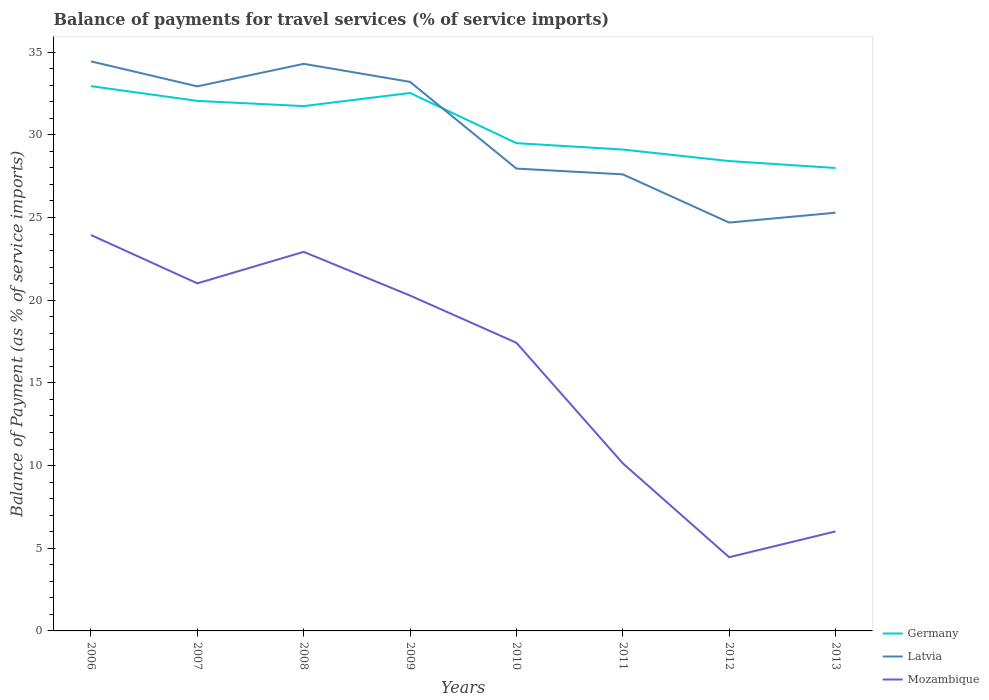How many different coloured lines are there?
Your answer should be very brief. 3. Is the number of lines equal to the number of legend labels?
Your answer should be very brief. Yes. Across all years, what is the maximum balance of payments for travel services in Latvia?
Provide a succinct answer. 24.69. What is the total balance of payments for travel services in Latvia in the graph?
Make the answer very short. 1.51. What is the difference between the highest and the second highest balance of payments for travel services in Germany?
Offer a very short reply. 4.95. Is the balance of payments for travel services in Mozambique strictly greater than the balance of payments for travel services in Germany over the years?
Your answer should be very brief. Yes. How many lines are there?
Your answer should be compact. 3. What is the difference between two consecutive major ticks on the Y-axis?
Keep it short and to the point. 5. How are the legend labels stacked?
Ensure brevity in your answer.  Vertical. What is the title of the graph?
Offer a very short reply. Balance of payments for travel services (% of service imports). What is the label or title of the X-axis?
Offer a terse response. Years. What is the label or title of the Y-axis?
Give a very brief answer. Balance of Payment (as % of service imports). What is the Balance of Payment (as % of service imports) in Germany in 2006?
Ensure brevity in your answer.  32.95. What is the Balance of Payment (as % of service imports) in Latvia in 2006?
Offer a terse response. 34.44. What is the Balance of Payment (as % of service imports) of Mozambique in 2006?
Make the answer very short. 23.94. What is the Balance of Payment (as % of service imports) in Germany in 2007?
Your response must be concise. 32.05. What is the Balance of Payment (as % of service imports) of Latvia in 2007?
Your response must be concise. 32.93. What is the Balance of Payment (as % of service imports) of Mozambique in 2007?
Offer a very short reply. 21.02. What is the Balance of Payment (as % of service imports) in Germany in 2008?
Give a very brief answer. 31.74. What is the Balance of Payment (as % of service imports) in Latvia in 2008?
Your answer should be compact. 34.29. What is the Balance of Payment (as % of service imports) in Mozambique in 2008?
Your answer should be compact. 22.92. What is the Balance of Payment (as % of service imports) in Germany in 2009?
Your answer should be very brief. 32.53. What is the Balance of Payment (as % of service imports) of Latvia in 2009?
Your answer should be compact. 33.2. What is the Balance of Payment (as % of service imports) in Mozambique in 2009?
Offer a terse response. 20.28. What is the Balance of Payment (as % of service imports) of Germany in 2010?
Provide a short and direct response. 29.5. What is the Balance of Payment (as % of service imports) in Latvia in 2010?
Provide a short and direct response. 27.96. What is the Balance of Payment (as % of service imports) of Mozambique in 2010?
Your answer should be very brief. 17.43. What is the Balance of Payment (as % of service imports) of Germany in 2011?
Keep it short and to the point. 29.11. What is the Balance of Payment (as % of service imports) in Latvia in 2011?
Keep it short and to the point. 27.61. What is the Balance of Payment (as % of service imports) of Mozambique in 2011?
Your answer should be very brief. 10.14. What is the Balance of Payment (as % of service imports) in Germany in 2012?
Keep it short and to the point. 28.41. What is the Balance of Payment (as % of service imports) in Latvia in 2012?
Keep it short and to the point. 24.69. What is the Balance of Payment (as % of service imports) of Mozambique in 2012?
Your answer should be compact. 4.46. What is the Balance of Payment (as % of service imports) in Germany in 2013?
Offer a terse response. 27.99. What is the Balance of Payment (as % of service imports) in Latvia in 2013?
Make the answer very short. 25.29. What is the Balance of Payment (as % of service imports) of Mozambique in 2013?
Keep it short and to the point. 6.02. Across all years, what is the maximum Balance of Payment (as % of service imports) in Germany?
Make the answer very short. 32.95. Across all years, what is the maximum Balance of Payment (as % of service imports) of Latvia?
Offer a very short reply. 34.44. Across all years, what is the maximum Balance of Payment (as % of service imports) in Mozambique?
Keep it short and to the point. 23.94. Across all years, what is the minimum Balance of Payment (as % of service imports) of Germany?
Your answer should be compact. 27.99. Across all years, what is the minimum Balance of Payment (as % of service imports) in Latvia?
Your answer should be compact. 24.69. Across all years, what is the minimum Balance of Payment (as % of service imports) in Mozambique?
Offer a terse response. 4.46. What is the total Balance of Payment (as % of service imports) in Germany in the graph?
Your response must be concise. 244.29. What is the total Balance of Payment (as % of service imports) of Latvia in the graph?
Your answer should be compact. 240.43. What is the total Balance of Payment (as % of service imports) in Mozambique in the graph?
Provide a succinct answer. 126.21. What is the difference between the Balance of Payment (as % of service imports) in Germany in 2006 and that in 2007?
Make the answer very short. 0.89. What is the difference between the Balance of Payment (as % of service imports) in Latvia in 2006 and that in 2007?
Your response must be concise. 1.51. What is the difference between the Balance of Payment (as % of service imports) in Mozambique in 2006 and that in 2007?
Provide a succinct answer. 2.92. What is the difference between the Balance of Payment (as % of service imports) of Germany in 2006 and that in 2008?
Your answer should be compact. 1.21. What is the difference between the Balance of Payment (as % of service imports) of Latvia in 2006 and that in 2008?
Offer a very short reply. 0.15. What is the difference between the Balance of Payment (as % of service imports) of Mozambique in 2006 and that in 2008?
Give a very brief answer. 1.02. What is the difference between the Balance of Payment (as % of service imports) in Germany in 2006 and that in 2009?
Provide a succinct answer. 0.41. What is the difference between the Balance of Payment (as % of service imports) in Latvia in 2006 and that in 2009?
Provide a succinct answer. 1.24. What is the difference between the Balance of Payment (as % of service imports) of Mozambique in 2006 and that in 2009?
Your answer should be very brief. 3.66. What is the difference between the Balance of Payment (as % of service imports) of Germany in 2006 and that in 2010?
Your response must be concise. 3.45. What is the difference between the Balance of Payment (as % of service imports) in Latvia in 2006 and that in 2010?
Your response must be concise. 6.48. What is the difference between the Balance of Payment (as % of service imports) in Mozambique in 2006 and that in 2010?
Make the answer very short. 6.51. What is the difference between the Balance of Payment (as % of service imports) of Germany in 2006 and that in 2011?
Offer a very short reply. 3.84. What is the difference between the Balance of Payment (as % of service imports) of Latvia in 2006 and that in 2011?
Provide a succinct answer. 6.83. What is the difference between the Balance of Payment (as % of service imports) of Mozambique in 2006 and that in 2011?
Give a very brief answer. 13.8. What is the difference between the Balance of Payment (as % of service imports) in Germany in 2006 and that in 2012?
Your answer should be compact. 4.53. What is the difference between the Balance of Payment (as % of service imports) of Latvia in 2006 and that in 2012?
Keep it short and to the point. 9.75. What is the difference between the Balance of Payment (as % of service imports) of Mozambique in 2006 and that in 2012?
Offer a terse response. 19.48. What is the difference between the Balance of Payment (as % of service imports) of Germany in 2006 and that in 2013?
Provide a short and direct response. 4.95. What is the difference between the Balance of Payment (as % of service imports) in Latvia in 2006 and that in 2013?
Give a very brief answer. 9.15. What is the difference between the Balance of Payment (as % of service imports) in Mozambique in 2006 and that in 2013?
Offer a very short reply. 17.92. What is the difference between the Balance of Payment (as % of service imports) in Germany in 2007 and that in 2008?
Provide a short and direct response. 0.32. What is the difference between the Balance of Payment (as % of service imports) of Latvia in 2007 and that in 2008?
Keep it short and to the point. -1.36. What is the difference between the Balance of Payment (as % of service imports) of Mozambique in 2007 and that in 2008?
Make the answer very short. -1.9. What is the difference between the Balance of Payment (as % of service imports) of Germany in 2007 and that in 2009?
Your response must be concise. -0.48. What is the difference between the Balance of Payment (as % of service imports) of Latvia in 2007 and that in 2009?
Offer a very short reply. -0.27. What is the difference between the Balance of Payment (as % of service imports) in Mozambique in 2007 and that in 2009?
Keep it short and to the point. 0.74. What is the difference between the Balance of Payment (as % of service imports) of Germany in 2007 and that in 2010?
Give a very brief answer. 2.56. What is the difference between the Balance of Payment (as % of service imports) of Latvia in 2007 and that in 2010?
Give a very brief answer. 4.97. What is the difference between the Balance of Payment (as % of service imports) in Mozambique in 2007 and that in 2010?
Provide a succinct answer. 3.59. What is the difference between the Balance of Payment (as % of service imports) in Germany in 2007 and that in 2011?
Provide a short and direct response. 2.94. What is the difference between the Balance of Payment (as % of service imports) in Latvia in 2007 and that in 2011?
Offer a very short reply. 5.32. What is the difference between the Balance of Payment (as % of service imports) in Mozambique in 2007 and that in 2011?
Ensure brevity in your answer.  10.88. What is the difference between the Balance of Payment (as % of service imports) in Germany in 2007 and that in 2012?
Make the answer very short. 3.64. What is the difference between the Balance of Payment (as % of service imports) in Latvia in 2007 and that in 2012?
Offer a very short reply. 8.24. What is the difference between the Balance of Payment (as % of service imports) of Mozambique in 2007 and that in 2012?
Ensure brevity in your answer.  16.56. What is the difference between the Balance of Payment (as % of service imports) of Germany in 2007 and that in 2013?
Your answer should be compact. 4.06. What is the difference between the Balance of Payment (as % of service imports) of Latvia in 2007 and that in 2013?
Provide a succinct answer. 7.64. What is the difference between the Balance of Payment (as % of service imports) in Mozambique in 2007 and that in 2013?
Your response must be concise. 15. What is the difference between the Balance of Payment (as % of service imports) of Germany in 2008 and that in 2009?
Ensure brevity in your answer.  -0.79. What is the difference between the Balance of Payment (as % of service imports) in Latvia in 2008 and that in 2009?
Your answer should be compact. 1.09. What is the difference between the Balance of Payment (as % of service imports) of Mozambique in 2008 and that in 2009?
Offer a terse response. 2.64. What is the difference between the Balance of Payment (as % of service imports) of Germany in 2008 and that in 2010?
Offer a very short reply. 2.24. What is the difference between the Balance of Payment (as % of service imports) of Latvia in 2008 and that in 2010?
Keep it short and to the point. 6.33. What is the difference between the Balance of Payment (as % of service imports) of Mozambique in 2008 and that in 2010?
Provide a succinct answer. 5.5. What is the difference between the Balance of Payment (as % of service imports) of Germany in 2008 and that in 2011?
Offer a very short reply. 2.63. What is the difference between the Balance of Payment (as % of service imports) in Latvia in 2008 and that in 2011?
Give a very brief answer. 6.68. What is the difference between the Balance of Payment (as % of service imports) of Mozambique in 2008 and that in 2011?
Provide a succinct answer. 12.79. What is the difference between the Balance of Payment (as % of service imports) of Germany in 2008 and that in 2012?
Provide a short and direct response. 3.32. What is the difference between the Balance of Payment (as % of service imports) of Latvia in 2008 and that in 2012?
Provide a succinct answer. 9.6. What is the difference between the Balance of Payment (as % of service imports) of Mozambique in 2008 and that in 2012?
Offer a terse response. 18.47. What is the difference between the Balance of Payment (as % of service imports) of Germany in 2008 and that in 2013?
Your response must be concise. 3.74. What is the difference between the Balance of Payment (as % of service imports) in Latvia in 2008 and that in 2013?
Keep it short and to the point. 9. What is the difference between the Balance of Payment (as % of service imports) in Mozambique in 2008 and that in 2013?
Provide a short and direct response. 16.91. What is the difference between the Balance of Payment (as % of service imports) of Germany in 2009 and that in 2010?
Offer a terse response. 3.03. What is the difference between the Balance of Payment (as % of service imports) of Latvia in 2009 and that in 2010?
Keep it short and to the point. 5.24. What is the difference between the Balance of Payment (as % of service imports) of Mozambique in 2009 and that in 2010?
Provide a short and direct response. 2.86. What is the difference between the Balance of Payment (as % of service imports) of Germany in 2009 and that in 2011?
Provide a succinct answer. 3.42. What is the difference between the Balance of Payment (as % of service imports) of Latvia in 2009 and that in 2011?
Give a very brief answer. 5.59. What is the difference between the Balance of Payment (as % of service imports) in Mozambique in 2009 and that in 2011?
Give a very brief answer. 10.14. What is the difference between the Balance of Payment (as % of service imports) of Germany in 2009 and that in 2012?
Provide a short and direct response. 4.12. What is the difference between the Balance of Payment (as % of service imports) in Latvia in 2009 and that in 2012?
Offer a terse response. 8.51. What is the difference between the Balance of Payment (as % of service imports) in Mozambique in 2009 and that in 2012?
Your response must be concise. 15.82. What is the difference between the Balance of Payment (as % of service imports) in Germany in 2009 and that in 2013?
Provide a succinct answer. 4.54. What is the difference between the Balance of Payment (as % of service imports) of Latvia in 2009 and that in 2013?
Your response must be concise. 7.91. What is the difference between the Balance of Payment (as % of service imports) of Mozambique in 2009 and that in 2013?
Offer a terse response. 14.26. What is the difference between the Balance of Payment (as % of service imports) in Germany in 2010 and that in 2011?
Give a very brief answer. 0.39. What is the difference between the Balance of Payment (as % of service imports) of Latvia in 2010 and that in 2011?
Your answer should be very brief. 0.35. What is the difference between the Balance of Payment (as % of service imports) in Mozambique in 2010 and that in 2011?
Your answer should be very brief. 7.29. What is the difference between the Balance of Payment (as % of service imports) in Germany in 2010 and that in 2012?
Your answer should be compact. 1.08. What is the difference between the Balance of Payment (as % of service imports) of Latvia in 2010 and that in 2012?
Your response must be concise. 3.26. What is the difference between the Balance of Payment (as % of service imports) in Mozambique in 2010 and that in 2012?
Provide a short and direct response. 12.97. What is the difference between the Balance of Payment (as % of service imports) of Germany in 2010 and that in 2013?
Make the answer very short. 1.5. What is the difference between the Balance of Payment (as % of service imports) of Latvia in 2010 and that in 2013?
Keep it short and to the point. 2.67. What is the difference between the Balance of Payment (as % of service imports) of Mozambique in 2010 and that in 2013?
Your answer should be compact. 11.41. What is the difference between the Balance of Payment (as % of service imports) in Germany in 2011 and that in 2012?
Provide a short and direct response. 0.69. What is the difference between the Balance of Payment (as % of service imports) in Latvia in 2011 and that in 2012?
Make the answer very short. 2.92. What is the difference between the Balance of Payment (as % of service imports) of Mozambique in 2011 and that in 2012?
Make the answer very short. 5.68. What is the difference between the Balance of Payment (as % of service imports) in Germany in 2011 and that in 2013?
Make the answer very short. 1.11. What is the difference between the Balance of Payment (as % of service imports) in Latvia in 2011 and that in 2013?
Provide a short and direct response. 2.32. What is the difference between the Balance of Payment (as % of service imports) of Mozambique in 2011 and that in 2013?
Your answer should be very brief. 4.12. What is the difference between the Balance of Payment (as % of service imports) in Germany in 2012 and that in 2013?
Your response must be concise. 0.42. What is the difference between the Balance of Payment (as % of service imports) of Latvia in 2012 and that in 2013?
Offer a terse response. -0.6. What is the difference between the Balance of Payment (as % of service imports) of Mozambique in 2012 and that in 2013?
Offer a terse response. -1.56. What is the difference between the Balance of Payment (as % of service imports) in Germany in 2006 and the Balance of Payment (as % of service imports) in Latvia in 2007?
Offer a very short reply. 0.01. What is the difference between the Balance of Payment (as % of service imports) of Germany in 2006 and the Balance of Payment (as % of service imports) of Mozambique in 2007?
Offer a terse response. 11.93. What is the difference between the Balance of Payment (as % of service imports) of Latvia in 2006 and the Balance of Payment (as % of service imports) of Mozambique in 2007?
Offer a terse response. 13.42. What is the difference between the Balance of Payment (as % of service imports) of Germany in 2006 and the Balance of Payment (as % of service imports) of Latvia in 2008?
Provide a short and direct response. -1.35. What is the difference between the Balance of Payment (as % of service imports) in Germany in 2006 and the Balance of Payment (as % of service imports) in Mozambique in 2008?
Give a very brief answer. 10.02. What is the difference between the Balance of Payment (as % of service imports) of Latvia in 2006 and the Balance of Payment (as % of service imports) of Mozambique in 2008?
Offer a terse response. 11.52. What is the difference between the Balance of Payment (as % of service imports) of Germany in 2006 and the Balance of Payment (as % of service imports) of Latvia in 2009?
Your answer should be compact. -0.26. What is the difference between the Balance of Payment (as % of service imports) of Germany in 2006 and the Balance of Payment (as % of service imports) of Mozambique in 2009?
Keep it short and to the point. 12.66. What is the difference between the Balance of Payment (as % of service imports) of Latvia in 2006 and the Balance of Payment (as % of service imports) of Mozambique in 2009?
Your response must be concise. 14.16. What is the difference between the Balance of Payment (as % of service imports) in Germany in 2006 and the Balance of Payment (as % of service imports) in Latvia in 2010?
Keep it short and to the point. 4.99. What is the difference between the Balance of Payment (as % of service imports) in Germany in 2006 and the Balance of Payment (as % of service imports) in Mozambique in 2010?
Your answer should be very brief. 15.52. What is the difference between the Balance of Payment (as % of service imports) in Latvia in 2006 and the Balance of Payment (as % of service imports) in Mozambique in 2010?
Keep it short and to the point. 17.02. What is the difference between the Balance of Payment (as % of service imports) of Germany in 2006 and the Balance of Payment (as % of service imports) of Latvia in 2011?
Give a very brief answer. 5.33. What is the difference between the Balance of Payment (as % of service imports) of Germany in 2006 and the Balance of Payment (as % of service imports) of Mozambique in 2011?
Your response must be concise. 22.81. What is the difference between the Balance of Payment (as % of service imports) of Latvia in 2006 and the Balance of Payment (as % of service imports) of Mozambique in 2011?
Provide a succinct answer. 24.3. What is the difference between the Balance of Payment (as % of service imports) in Germany in 2006 and the Balance of Payment (as % of service imports) in Latvia in 2012?
Your answer should be compact. 8.25. What is the difference between the Balance of Payment (as % of service imports) of Germany in 2006 and the Balance of Payment (as % of service imports) of Mozambique in 2012?
Give a very brief answer. 28.49. What is the difference between the Balance of Payment (as % of service imports) of Latvia in 2006 and the Balance of Payment (as % of service imports) of Mozambique in 2012?
Keep it short and to the point. 29.99. What is the difference between the Balance of Payment (as % of service imports) in Germany in 2006 and the Balance of Payment (as % of service imports) in Latvia in 2013?
Give a very brief answer. 7.65. What is the difference between the Balance of Payment (as % of service imports) in Germany in 2006 and the Balance of Payment (as % of service imports) in Mozambique in 2013?
Ensure brevity in your answer.  26.93. What is the difference between the Balance of Payment (as % of service imports) in Latvia in 2006 and the Balance of Payment (as % of service imports) in Mozambique in 2013?
Give a very brief answer. 28.43. What is the difference between the Balance of Payment (as % of service imports) of Germany in 2007 and the Balance of Payment (as % of service imports) of Latvia in 2008?
Provide a succinct answer. -2.24. What is the difference between the Balance of Payment (as % of service imports) in Germany in 2007 and the Balance of Payment (as % of service imports) in Mozambique in 2008?
Ensure brevity in your answer.  9.13. What is the difference between the Balance of Payment (as % of service imports) of Latvia in 2007 and the Balance of Payment (as % of service imports) of Mozambique in 2008?
Provide a succinct answer. 10.01. What is the difference between the Balance of Payment (as % of service imports) of Germany in 2007 and the Balance of Payment (as % of service imports) of Latvia in 2009?
Your answer should be compact. -1.15. What is the difference between the Balance of Payment (as % of service imports) in Germany in 2007 and the Balance of Payment (as % of service imports) in Mozambique in 2009?
Make the answer very short. 11.77. What is the difference between the Balance of Payment (as % of service imports) in Latvia in 2007 and the Balance of Payment (as % of service imports) in Mozambique in 2009?
Ensure brevity in your answer.  12.65. What is the difference between the Balance of Payment (as % of service imports) in Germany in 2007 and the Balance of Payment (as % of service imports) in Latvia in 2010?
Your answer should be compact. 4.09. What is the difference between the Balance of Payment (as % of service imports) in Germany in 2007 and the Balance of Payment (as % of service imports) in Mozambique in 2010?
Provide a short and direct response. 14.63. What is the difference between the Balance of Payment (as % of service imports) of Latvia in 2007 and the Balance of Payment (as % of service imports) of Mozambique in 2010?
Offer a very short reply. 15.51. What is the difference between the Balance of Payment (as % of service imports) of Germany in 2007 and the Balance of Payment (as % of service imports) of Latvia in 2011?
Your response must be concise. 4.44. What is the difference between the Balance of Payment (as % of service imports) in Germany in 2007 and the Balance of Payment (as % of service imports) in Mozambique in 2011?
Your answer should be compact. 21.91. What is the difference between the Balance of Payment (as % of service imports) in Latvia in 2007 and the Balance of Payment (as % of service imports) in Mozambique in 2011?
Make the answer very short. 22.79. What is the difference between the Balance of Payment (as % of service imports) of Germany in 2007 and the Balance of Payment (as % of service imports) of Latvia in 2012?
Offer a very short reply. 7.36. What is the difference between the Balance of Payment (as % of service imports) of Germany in 2007 and the Balance of Payment (as % of service imports) of Mozambique in 2012?
Your answer should be very brief. 27.6. What is the difference between the Balance of Payment (as % of service imports) in Latvia in 2007 and the Balance of Payment (as % of service imports) in Mozambique in 2012?
Give a very brief answer. 28.47. What is the difference between the Balance of Payment (as % of service imports) of Germany in 2007 and the Balance of Payment (as % of service imports) of Latvia in 2013?
Your response must be concise. 6.76. What is the difference between the Balance of Payment (as % of service imports) of Germany in 2007 and the Balance of Payment (as % of service imports) of Mozambique in 2013?
Give a very brief answer. 26.04. What is the difference between the Balance of Payment (as % of service imports) of Latvia in 2007 and the Balance of Payment (as % of service imports) of Mozambique in 2013?
Keep it short and to the point. 26.91. What is the difference between the Balance of Payment (as % of service imports) in Germany in 2008 and the Balance of Payment (as % of service imports) in Latvia in 2009?
Your response must be concise. -1.47. What is the difference between the Balance of Payment (as % of service imports) in Germany in 2008 and the Balance of Payment (as % of service imports) in Mozambique in 2009?
Provide a short and direct response. 11.46. What is the difference between the Balance of Payment (as % of service imports) of Latvia in 2008 and the Balance of Payment (as % of service imports) of Mozambique in 2009?
Offer a terse response. 14.01. What is the difference between the Balance of Payment (as % of service imports) of Germany in 2008 and the Balance of Payment (as % of service imports) of Latvia in 2010?
Keep it short and to the point. 3.78. What is the difference between the Balance of Payment (as % of service imports) in Germany in 2008 and the Balance of Payment (as % of service imports) in Mozambique in 2010?
Ensure brevity in your answer.  14.31. What is the difference between the Balance of Payment (as % of service imports) of Latvia in 2008 and the Balance of Payment (as % of service imports) of Mozambique in 2010?
Your response must be concise. 16.87. What is the difference between the Balance of Payment (as % of service imports) of Germany in 2008 and the Balance of Payment (as % of service imports) of Latvia in 2011?
Your answer should be compact. 4.13. What is the difference between the Balance of Payment (as % of service imports) of Germany in 2008 and the Balance of Payment (as % of service imports) of Mozambique in 2011?
Your answer should be compact. 21.6. What is the difference between the Balance of Payment (as % of service imports) of Latvia in 2008 and the Balance of Payment (as % of service imports) of Mozambique in 2011?
Give a very brief answer. 24.15. What is the difference between the Balance of Payment (as % of service imports) of Germany in 2008 and the Balance of Payment (as % of service imports) of Latvia in 2012?
Your answer should be very brief. 7.04. What is the difference between the Balance of Payment (as % of service imports) of Germany in 2008 and the Balance of Payment (as % of service imports) of Mozambique in 2012?
Ensure brevity in your answer.  27.28. What is the difference between the Balance of Payment (as % of service imports) of Latvia in 2008 and the Balance of Payment (as % of service imports) of Mozambique in 2012?
Your answer should be compact. 29.84. What is the difference between the Balance of Payment (as % of service imports) of Germany in 2008 and the Balance of Payment (as % of service imports) of Latvia in 2013?
Provide a succinct answer. 6.45. What is the difference between the Balance of Payment (as % of service imports) in Germany in 2008 and the Balance of Payment (as % of service imports) in Mozambique in 2013?
Your response must be concise. 25.72. What is the difference between the Balance of Payment (as % of service imports) in Latvia in 2008 and the Balance of Payment (as % of service imports) in Mozambique in 2013?
Offer a very short reply. 28.28. What is the difference between the Balance of Payment (as % of service imports) in Germany in 2009 and the Balance of Payment (as % of service imports) in Latvia in 2010?
Provide a succinct answer. 4.57. What is the difference between the Balance of Payment (as % of service imports) in Germany in 2009 and the Balance of Payment (as % of service imports) in Mozambique in 2010?
Offer a terse response. 15.11. What is the difference between the Balance of Payment (as % of service imports) in Latvia in 2009 and the Balance of Payment (as % of service imports) in Mozambique in 2010?
Keep it short and to the point. 15.78. What is the difference between the Balance of Payment (as % of service imports) of Germany in 2009 and the Balance of Payment (as % of service imports) of Latvia in 2011?
Your answer should be compact. 4.92. What is the difference between the Balance of Payment (as % of service imports) of Germany in 2009 and the Balance of Payment (as % of service imports) of Mozambique in 2011?
Provide a succinct answer. 22.39. What is the difference between the Balance of Payment (as % of service imports) in Latvia in 2009 and the Balance of Payment (as % of service imports) in Mozambique in 2011?
Your answer should be very brief. 23.06. What is the difference between the Balance of Payment (as % of service imports) of Germany in 2009 and the Balance of Payment (as % of service imports) of Latvia in 2012?
Provide a short and direct response. 7.84. What is the difference between the Balance of Payment (as % of service imports) in Germany in 2009 and the Balance of Payment (as % of service imports) in Mozambique in 2012?
Ensure brevity in your answer.  28.07. What is the difference between the Balance of Payment (as % of service imports) in Latvia in 2009 and the Balance of Payment (as % of service imports) in Mozambique in 2012?
Ensure brevity in your answer.  28.75. What is the difference between the Balance of Payment (as % of service imports) in Germany in 2009 and the Balance of Payment (as % of service imports) in Latvia in 2013?
Offer a very short reply. 7.24. What is the difference between the Balance of Payment (as % of service imports) in Germany in 2009 and the Balance of Payment (as % of service imports) in Mozambique in 2013?
Your answer should be compact. 26.51. What is the difference between the Balance of Payment (as % of service imports) of Latvia in 2009 and the Balance of Payment (as % of service imports) of Mozambique in 2013?
Your answer should be very brief. 27.19. What is the difference between the Balance of Payment (as % of service imports) in Germany in 2010 and the Balance of Payment (as % of service imports) in Latvia in 2011?
Keep it short and to the point. 1.89. What is the difference between the Balance of Payment (as % of service imports) in Germany in 2010 and the Balance of Payment (as % of service imports) in Mozambique in 2011?
Your response must be concise. 19.36. What is the difference between the Balance of Payment (as % of service imports) in Latvia in 2010 and the Balance of Payment (as % of service imports) in Mozambique in 2011?
Offer a terse response. 17.82. What is the difference between the Balance of Payment (as % of service imports) in Germany in 2010 and the Balance of Payment (as % of service imports) in Latvia in 2012?
Keep it short and to the point. 4.8. What is the difference between the Balance of Payment (as % of service imports) in Germany in 2010 and the Balance of Payment (as % of service imports) in Mozambique in 2012?
Provide a short and direct response. 25.04. What is the difference between the Balance of Payment (as % of service imports) of Latvia in 2010 and the Balance of Payment (as % of service imports) of Mozambique in 2012?
Your answer should be compact. 23.5. What is the difference between the Balance of Payment (as % of service imports) of Germany in 2010 and the Balance of Payment (as % of service imports) of Latvia in 2013?
Make the answer very short. 4.21. What is the difference between the Balance of Payment (as % of service imports) in Germany in 2010 and the Balance of Payment (as % of service imports) in Mozambique in 2013?
Your response must be concise. 23.48. What is the difference between the Balance of Payment (as % of service imports) in Latvia in 2010 and the Balance of Payment (as % of service imports) in Mozambique in 2013?
Your response must be concise. 21.94. What is the difference between the Balance of Payment (as % of service imports) in Germany in 2011 and the Balance of Payment (as % of service imports) in Latvia in 2012?
Offer a very short reply. 4.42. What is the difference between the Balance of Payment (as % of service imports) in Germany in 2011 and the Balance of Payment (as % of service imports) in Mozambique in 2012?
Your answer should be compact. 24.65. What is the difference between the Balance of Payment (as % of service imports) in Latvia in 2011 and the Balance of Payment (as % of service imports) in Mozambique in 2012?
Provide a succinct answer. 23.15. What is the difference between the Balance of Payment (as % of service imports) in Germany in 2011 and the Balance of Payment (as % of service imports) in Latvia in 2013?
Provide a succinct answer. 3.82. What is the difference between the Balance of Payment (as % of service imports) of Germany in 2011 and the Balance of Payment (as % of service imports) of Mozambique in 2013?
Your answer should be compact. 23.09. What is the difference between the Balance of Payment (as % of service imports) of Latvia in 2011 and the Balance of Payment (as % of service imports) of Mozambique in 2013?
Provide a short and direct response. 21.59. What is the difference between the Balance of Payment (as % of service imports) in Germany in 2012 and the Balance of Payment (as % of service imports) in Latvia in 2013?
Your answer should be very brief. 3.12. What is the difference between the Balance of Payment (as % of service imports) of Germany in 2012 and the Balance of Payment (as % of service imports) of Mozambique in 2013?
Offer a very short reply. 22.4. What is the difference between the Balance of Payment (as % of service imports) of Latvia in 2012 and the Balance of Payment (as % of service imports) of Mozambique in 2013?
Offer a very short reply. 18.68. What is the average Balance of Payment (as % of service imports) of Germany per year?
Keep it short and to the point. 30.54. What is the average Balance of Payment (as % of service imports) of Latvia per year?
Your response must be concise. 30.05. What is the average Balance of Payment (as % of service imports) in Mozambique per year?
Keep it short and to the point. 15.78. In the year 2006, what is the difference between the Balance of Payment (as % of service imports) in Germany and Balance of Payment (as % of service imports) in Latvia?
Give a very brief answer. -1.5. In the year 2006, what is the difference between the Balance of Payment (as % of service imports) of Germany and Balance of Payment (as % of service imports) of Mozambique?
Ensure brevity in your answer.  9. In the year 2006, what is the difference between the Balance of Payment (as % of service imports) of Latvia and Balance of Payment (as % of service imports) of Mozambique?
Your answer should be compact. 10.5. In the year 2007, what is the difference between the Balance of Payment (as % of service imports) of Germany and Balance of Payment (as % of service imports) of Latvia?
Your answer should be very brief. -0.88. In the year 2007, what is the difference between the Balance of Payment (as % of service imports) of Germany and Balance of Payment (as % of service imports) of Mozambique?
Offer a very short reply. 11.03. In the year 2007, what is the difference between the Balance of Payment (as % of service imports) of Latvia and Balance of Payment (as % of service imports) of Mozambique?
Provide a short and direct response. 11.91. In the year 2008, what is the difference between the Balance of Payment (as % of service imports) in Germany and Balance of Payment (as % of service imports) in Latvia?
Keep it short and to the point. -2.55. In the year 2008, what is the difference between the Balance of Payment (as % of service imports) in Germany and Balance of Payment (as % of service imports) in Mozambique?
Ensure brevity in your answer.  8.81. In the year 2008, what is the difference between the Balance of Payment (as % of service imports) of Latvia and Balance of Payment (as % of service imports) of Mozambique?
Keep it short and to the point. 11.37. In the year 2009, what is the difference between the Balance of Payment (as % of service imports) of Germany and Balance of Payment (as % of service imports) of Latvia?
Your response must be concise. -0.67. In the year 2009, what is the difference between the Balance of Payment (as % of service imports) in Germany and Balance of Payment (as % of service imports) in Mozambique?
Offer a terse response. 12.25. In the year 2009, what is the difference between the Balance of Payment (as % of service imports) of Latvia and Balance of Payment (as % of service imports) of Mozambique?
Keep it short and to the point. 12.92. In the year 2010, what is the difference between the Balance of Payment (as % of service imports) in Germany and Balance of Payment (as % of service imports) in Latvia?
Give a very brief answer. 1.54. In the year 2010, what is the difference between the Balance of Payment (as % of service imports) of Germany and Balance of Payment (as % of service imports) of Mozambique?
Offer a terse response. 12.07. In the year 2010, what is the difference between the Balance of Payment (as % of service imports) of Latvia and Balance of Payment (as % of service imports) of Mozambique?
Provide a short and direct response. 10.53. In the year 2011, what is the difference between the Balance of Payment (as % of service imports) of Germany and Balance of Payment (as % of service imports) of Latvia?
Your answer should be very brief. 1.5. In the year 2011, what is the difference between the Balance of Payment (as % of service imports) in Germany and Balance of Payment (as % of service imports) in Mozambique?
Provide a short and direct response. 18.97. In the year 2011, what is the difference between the Balance of Payment (as % of service imports) of Latvia and Balance of Payment (as % of service imports) of Mozambique?
Keep it short and to the point. 17.47. In the year 2012, what is the difference between the Balance of Payment (as % of service imports) of Germany and Balance of Payment (as % of service imports) of Latvia?
Provide a short and direct response. 3.72. In the year 2012, what is the difference between the Balance of Payment (as % of service imports) of Germany and Balance of Payment (as % of service imports) of Mozambique?
Your answer should be very brief. 23.96. In the year 2012, what is the difference between the Balance of Payment (as % of service imports) of Latvia and Balance of Payment (as % of service imports) of Mozambique?
Provide a succinct answer. 20.24. In the year 2013, what is the difference between the Balance of Payment (as % of service imports) of Germany and Balance of Payment (as % of service imports) of Latvia?
Your response must be concise. 2.7. In the year 2013, what is the difference between the Balance of Payment (as % of service imports) of Germany and Balance of Payment (as % of service imports) of Mozambique?
Offer a very short reply. 21.98. In the year 2013, what is the difference between the Balance of Payment (as % of service imports) of Latvia and Balance of Payment (as % of service imports) of Mozambique?
Your response must be concise. 19.27. What is the ratio of the Balance of Payment (as % of service imports) of Germany in 2006 to that in 2007?
Keep it short and to the point. 1.03. What is the ratio of the Balance of Payment (as % of service imports) in Latvia in 2006 to that in 2007?
Ensure brevity in your answer.  1.05. What is the ratio of the Balance of Payment (as % of service imports) of Mozambique in 2006 to that in 2007?
Ensure brevity in your answer.  1.14. What is the ratio of the Balance of Payment (as % of service imports) of Germany in 2006 to that in 2008?
Give a very brief answer. 1.04. What is the ratio of the Balance of Payment (as % of service imports) in Mozambique in 2006 to that in 2008?
Offer a very short reply. 1.04. What is the ratio of the Balance of Payment (as % of service imports) of Germany in 2006 to that in 2009?
Your answer should be very brief. 1.01. What is the ratio of the Balance of Payment (as % of service imports) of Latvia in 2006 to that in 2009?
Provide a short and direct response. 1.04. What is the ratio of the Balance of Payment (as % of service imports) in Mozambique in 2006 to that in 2009?
Offer a very short reply. 1.18. What is the ratio of the Balance of Payment (as % of service imports) of Germany in 2006 to that in 2010?
Provide a short and direct response. 1.12. What is the ratio of the Balance of Payment (as % of service imports) of Latvia in 2006 to that in 2010?
Offer a very short reply. 1.23. What is the ratio of the Balance of Payment (as % of service imports) of Mozambique in 2006 to that in 2010?
Your response must be concise. 1.37. What is the ratio of the Balance of Payment (as % of service imports) in Germany in 2006 to that in 2011?
Give a very brief answer. 1.13. What is the ratio of the Balance of Payment (as % of service imports) of Latvia in 2006 to that in 2011?
Your answer should be compact. 1.25. What is the ratio of the Balance of Payment (as % of service imports) of Mozambique in 2006 to that in 2011?
Keep it short and to the point. 2.36. What is the ratio of the Balance of Payment (as % of service imports) of Germany in 2006 to that in 2012?
Provide a short and direct response. 1.16. What is the ratio of the Balance of Payment (as % of service imports) in Latvia in 2006 to that in 2012?
Your answer should be compact. 1.39. What is the ratio of the Balance of Payment (as % of service imports) in Mozambique in 2006 to that in 2012?
Provide a succinct answer. 5.37. What is the ratio of the Balance of Payment (as % of service imports) in Germany in 2006 to that in 2013?
Give a very brief answer. 1.18. What is the ratio of the Balance of Payment (as % of service imports) of Latvia in 2006 to that in 2013?
Your response must be concise. 1.36. What is the ratio of the Balance of Payment (as % of service imports) in Mozambique in 2006 to that in 2013?
Make the answer very short. 3.98. What is the ratio of the Balance of Payment (as % of service imports) in Germany in 2007 to that in 2008?
Your answer should be compact. 1.01. What is the ratio of the Balance of Payment (as % of service imports) in Latvia in 2007 to that in 2008?
Your response must be concise. 0.96. What is the ratio of the Balance of Payment (as % of service imports) of Mozambique in 2007 to that in 2008?
Provide a succinct answer. 0.92. What is the ratio of the Balance of Payment (as % of service imports) in Latvia in 2007 to that in 2009?
Your answer should be compact. 0.99. What is the ratio of the Balance of Payment (as % of service imports) of Mozambique in 2007 to that in 2009?
Make the answer very short. 1.04. What is the ratio of the Balance of Payment (as % of service imports) of Germany in 2007 to that in 2010?
Offer a terse response. 1.09. What is the ratio of the Balance of Payment (as % of service imports) of Latvia in 2007 to that in 2010?
Provide a succinct answer. 1.18. What is the ratio of the Balance of Payment (as % of service imports) of Mozambique in 2007 to that in 2010?
Give a very brief answer. 1.21. What is the ratio of the Balance of Payment (as % of service imports) of Germany in 2007 to that in 2011?
Your answer should be compact. 1.1. What is the ratio of the Balance of Payment (as % of service imports) of Latvia in 2007 to that in 2011?
Offer a terse response. 1.19. What is the ratio of the Balance of Payment (as % of service imports) in Mozambique in 2007 to that in 2011?
Your answer should be very brief. 2.07. What is the ratio of the Balance of Payment (as % of service imports) in Germany in 2007 to that in 2012?
Your response must be concise. 1.13. What is the ratio of the Balance of Payment (as % of service imports) in Latvia in 2007 to that in 2012?
Provide a short and direct response. 1.33. What is the ratio of the Balance of Payment (as % of service imports) in Mozambique in 2007 to that in 2012?
Provide a succinct answer. 4.72. What is the ratio of the Balance of Payment (as % of service imports) of Germany in 2007 to that in 2013?
Provide a succinct answer. 1.15. What is the ratio of the Balance of Payment (as % of service imports) in Latvia in 2007 to that in 2013?
Your answer should be very brief. 1.3. What is the ratio of the Balance of Payment (as % of service imports) of Mozambique in 2007 to that in 2013?
Ensure brevity in your answer.  3.49. What is the ratio of the Balance of Payment (as % of service imports) in Germany in 2008 to that in 2009?
Your answer should be very brief. 0.98. What is the ratio of the Balance of Payment (as % of service imports) of Latvia in 2008 to that in 2009?
Offer a very short reply. 1.03. What is the ratio of the Balance of Payment (as % of service imports) in Mozambique in 2008 to that in 2009?
Make the answer very short. 1.13. What is the ratio of the Balance of Payment (as % of service imports) in Germany in 2008 to that in 2010?
Your response must be concise. 1.08. What is the ratio of the Balance of Payment (as % of service imports) of Latvia in 2008 to that in 2010?
Your answer should be very brief. 1.23. What is the ratio of the Balance of Payment (as % of service imports) in Mozambique in 2008 to that in 2010?
Provide a short and direct response. 1.32. What is the ratio of the Balance of Payment (as % of service imports) of Germany in 2008 to that in 2011?
Provide a short and direct response. 1.09. What is the ratio of the Balance of Payment (as % of service imports) of Latvia in 2008 to that in 2011?
Your answer should be compact. 1.24. What is the ratio of the Balance of Payment (as % of service imports) of Mozambique in 2008 to that in 2011?
Offer a very short reply. 2.26. What is the ratio of the Balance of Payment (as % of service imports) of Germany in 2008 to that in 2012?
Ensure brevity in your answer.  1.12. What is the ratio of the Balance of Payment (as % of service imports) of Latvia in 2008 to that in 2012?
Provide a succinct answer. 1.39. What is the ratio of the Balance of Payment (as % of service imports) of Mozambique in 2008 to that in 2012?
Your response must be concise. 5.14. What is the ratio of the Balance of Payment (as % of service imports) of Germany in 2008 to that in 2013?
Your response must be concise. 1.13. What is the ratio of the Balance of Payment (as % of service imports) in Latvia in 2008 to that in 2013?
Offer a very short reply. 1.36. What is the ratio of the Balance of Payment (as % of service imports) of Mozambique in 2008 to that in 2013?
Your answer should be very brief. 3.81. What is the ratio of the Balance of Payment (as % of service imports) of Germany in 2009 to that in 2010?
Provide a short and direct response. 1.1. What is the ratio of the Balance of Payment (as % of service imports) of Latvia in 2009 to that in 2010?
Ensure brevity in your answer.  1.19. What is the ratio of the Balance of Payment (as % of service imports) of Mozambique in 2009 to that in 2010?
Offer a terse response. 1.16. What is the ratio of the Balance of Payment (as % of service imports) in Germany in 2009 to that in 2011?
Make the answer very short. 1.12. What is the ratio of the Balance of Payment (as % of service imports) in Latvia in 2009 to that in 2011?
Make the answer very short. 1.2. What is the ratio of the Balance of Payment (as % of service imports) in Mozambique in 2009 to that in 2011?
Ensure brevity in your answer.  2. What is the ratio of the Balance of Payment (as % of service imports) of Germany in 2009 to that in 2012?
Offer a terse response. 1.14. What is the ratio of the Balance of Payment (as % of service imports) in Latvia in 2009 to that in 2012?
Provide a short and direct response. 1.34. What is the ratio of the Balance of Payment (as % of service imports) in Mozambique in 2009 to that in 2012?
Offer a very short reply. 4.55. What is the ratio of the Balance of Payment (as % of service imports) of Germany in 2009 to that in 2013?
Provide a succinct answer. 1.16. What is the ratio of the Balance of Payment (as % of service imports) in Latvia in 2009 to that in 2013?
Keep it short and to the point. 1.31. What is the ratio of the Balance of Payment (as % of service imports) in Mozambique in 2009 to that in 2013?
Your answer should be compact. 3.37. What is the ratio of the Balance of Payment (as % of service imports) in Germany in 2010 to that in 2011?
Offer a very short reply. 1.01. What is the ratio of the Balance of Payment (as % of service imports) in Latvia in 2010 to that in 2011?
Give a very brief answer. 1.01. What is the ratio of the Balance of Payment (as % of service imports) of Mozambique in 2010 to that in 2011?
Give a very brief answer. 1.72. What is the ratio of the Balance of Payment (as % of service imports) of Germany in 2010 to that in 2012?
Ensure brevity in your answer.  1.04. What is the ratio of the Balance of Payment (as % of service imports) in Latvia in 2010 to that in 2012?
Give a very brief answer. 1.13. What is the ratio of the Balance of Payment (as % of service imports) of Mozambique in 2010 to that in 2012?
Provide a succinct answer. 3.91. What is the ratio of the Balance of Payment (as % of service imports) in Germany in 2010 to that in 2013?
Provide a succinct answer. 1.05. What is the ratio of the Balance of Payment (as % of service imports) in Latvia in 2010 to that in 2013?
Offer a terse response. 1.11. What is the ratio of the Balance of Payment (as % of service imports) in Mozambique in 2010 to that in 2013?
Keep it short and to the point. 2.9. What is the ratio of the Balance of Payment (as % of service imports) in Germany in 2011 to that in 2012?
Offer a terse response. 1.02. What is the ratio of the Balance of Payment (as % of service imports) in Latvia in 2011 to that in 2012?
Provide a short and direct response. 1.12. What is the ratio of the Balance of Payment (as % of service imports) in Mozambique in 2011 to that in 2012?
Your response must be concise. 2.27. What is the ratio of the Balance of Payment (as % of service imports) in Germany in 2011 to that in 2013?
Provide a succinct answer. 1.04. What is the ratio of the Balance of Payment (as % of service imports) in Latvia in 2011 to that in 2013?
Ensure brevity in your answer.  1.09. What is the ratio of the Balance of Payment (as % of service imports) in Mozambique in 2011 to that in 2013?
Offer a terse response. 1.68. What is the ratio of the Balance of Payment (as % of service imports) in Latvia in 2012 to that in 2013?
Offer a terse response. 0.98. What is the ratio of the Balance of Payment (as % of service imports) of Mozambique in 2012 to that in 2013?
Give a very brief answer. 0.74. What is the difference between the highest and the second highest Balance of Payment (as % of service imports) of Germany?
Provide a succinct answer. 0.41. What is the difference between the highest and the second highest Balance of Payment (as % of service imports) of Latvia?
Make the answer very short. 0.15. What is the difference between the highest and the second highest Balance of Payment (as % of service imports) in Mozambique?
Ensure brevity in your answer.  1.02. What is the difference between the highest and the lowest Balance of Payment (as % of service imports) of Germany?
Provide a short and direct response. 4.95. What is the difference between the highest and the lowest Balance of Payment (as % of service imports) in Latvia?
Your answer should be compact. 9.75. What is the difference between the highest and the lowest Balance of Payment (as % of service imports) in Mozambique?
Offer a terse response. 19.48. 